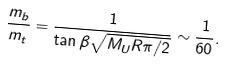<formula> <loc_0><loc_0><loc_500><loc_500>\frac { m _ { b } } { m _ { t } } = \frac { 1 } { \tan \beta \sqrt { M _ { U } R \pi / 2 } } \sim \frac { 1 } { 6 0 } .</formula> 